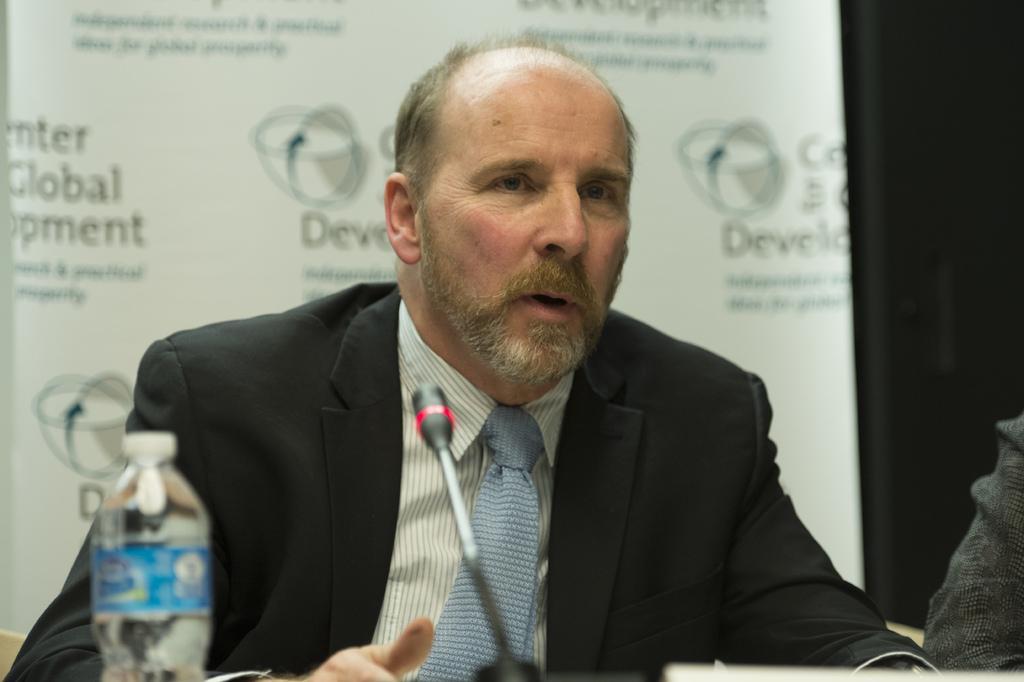Could you give a brief overview of what you see in this image? This picture shows a man seated and speaking with the help of a microphone and we see a bottle on the table and we see a hoarding back of them 